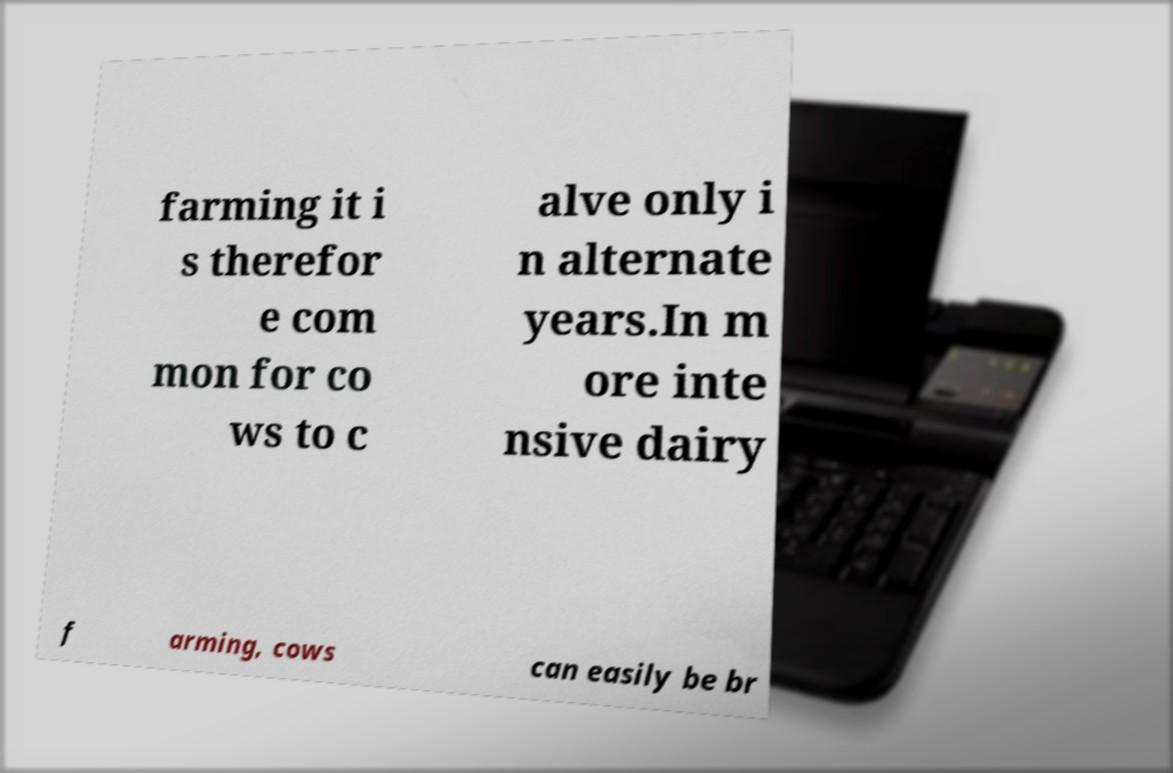Please read and relay the text visible in this image. What does it say? farming it i s therefor e com mon for co ws to c alve only i n alternate years.In m ore inte nsive dairy f arming, cows can easily be br 